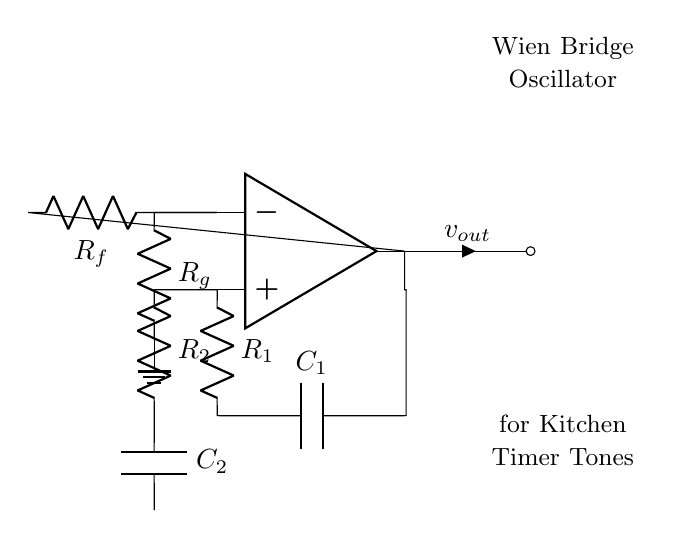What components are used in the oscillator? The oscillator uses resistors R1, R2, Rf, and Rg, and capacitors C1 and C2, along with an op-amp.
Answer: resistors and capacitors What type of feedback is used in this circuit? The circuit employs positive feedback from the op-amp's non-inverting terminal and negative feedback from the inverting terminal, enabling it to sustain oscillations.
Answer: Positive and negative feedback What is the function of the op-amp in the circuit? The op-amp amplifies the input signal and helps maintain oscillations by controlling the gain of the circuit.
Answer: Signal amplification Which components set the oscillation frequency? The oscillation frequency is determined by the resistors R1, R2, and the capacitors C1, C2, which form part of the bridge configuration.
Answer: R1, R2, C1, C2 What role do Rf and Rg play in the oscillator? Rf and Rg are used to regulate the gain of the amplifier and stabilize the output oscillation amplitude.
Answer: Gain regulation and stabilization What type of oscillator is represented in the diagram? This circuit is a Wien Bridge Oscillator, which is known for generating sinusoidal waveforms.
Answer: Wien Bridge Oscillator Which types of signals does this oscillator generate? The oscillator generates audio tones, typically in the range suitable for kitchen timers and alarms.
Answer: Audio tones 